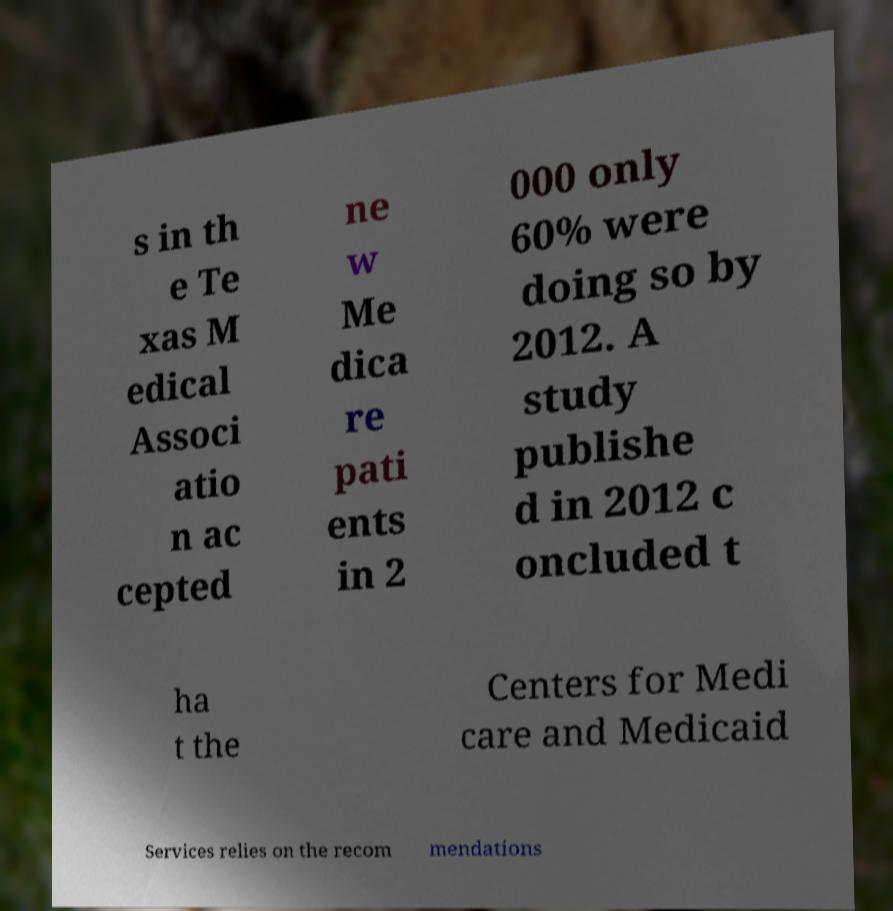There's text embedded in this image that I need extracted. Can you transcribe it verbatim? s in th e Te xas M edical Associ atio n ac cepted ne w Me dica re pati ents in 2 000 only 60% were doing so by 2012. A study publishe d in 2012 c oncluded t ha t the Centers for Medi care and Medicaid Services relies on the recom mendations 